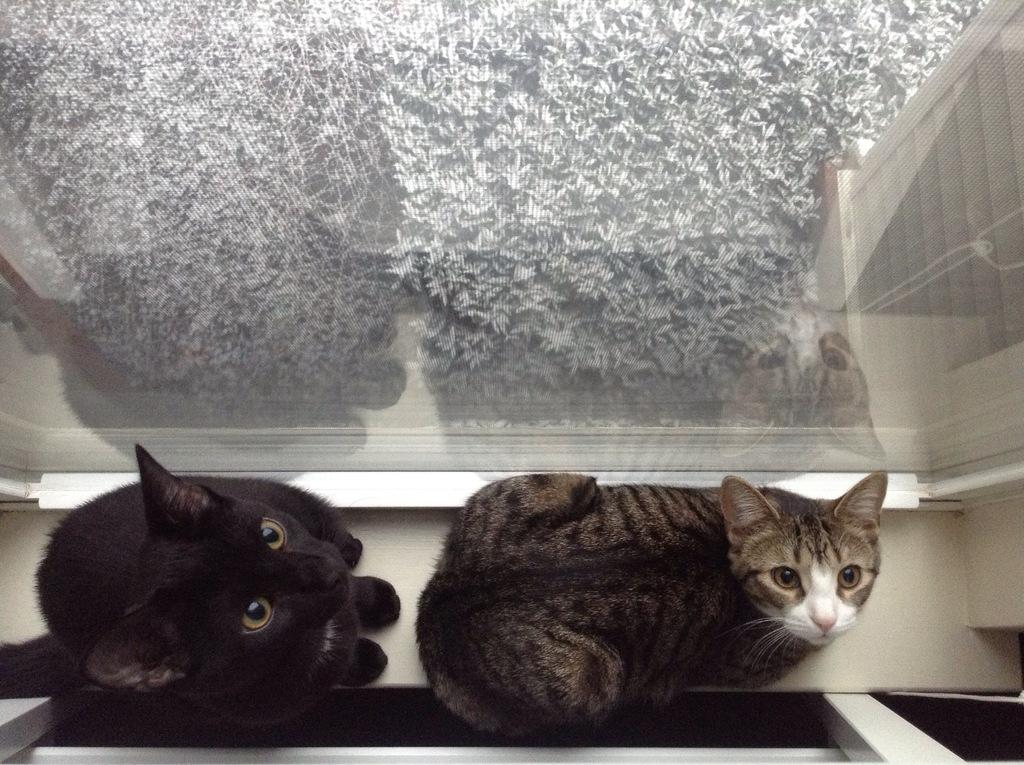Where was the image taken? The image was taken indoors. What animals can be seen in the foreground of the image? There are two cats in the foreground of the image. What are the cats doing in the image? The cats are sitting on the floor. What can be seen in the background of the image? There are objects visible in the background of the image. Is there a wound visible on one of the cats in the image? There is no indication of a wound on either of the cats in the image. What type of fiction is the cats reading in the image? The cats are not reading any fiction in the image; they are simply sitting on the floor. 